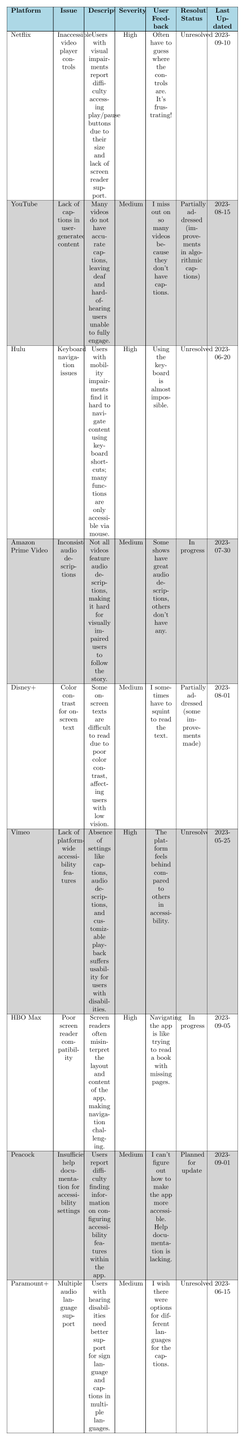What is the issue reported by Hulu? According to the table, Hulu reported "Keyboard navigation issues" as its usability issue.
Answer: Keyboard navigation issues Which platform has a high severity issue related to poor color contrast? The table indicates that Disney+ has a medium severity issue related to color contrast, while the other high severity issues are listed under platforms like Netflix, Hulu, Vimeo, and HBO Max, but none relate to color contrast.
Answer: None How many platforms report unresolved issues? By counting the "Resolution Status" column, there are four platforms (Netflix, Hulu, Vimeo, and Paramount+) that report issues as unresolved.
Answer: Four What is the user feedback for the issue reported by Peacock? The user feedback for Peacock states: "I can't figure out how to make the app more accessible. Help documentation is lacking." This feedback indicates a specific concern related to help documentation.
Answer: "I can't figure out how to make the app more accessible. Help documentation is lacking." Which platform has an issue regarding audio descriptions? The table shows that Amazon Prime Video has the issue of "Inconsistent audio descriptions."
Answer: Amazon Prime Video Are there any platforms that have a resolution status of "In progress"? Yes, both HBO Max and Amazon Prime Video have their resolution status listed as "In progress."
Answer: Yes What is the last updated date for the issue regarding inaccessible video player controls on Netflix? The table provides the last updated date for Netflix's issue as "2023-09-10."
Answer: 2023-09-10 Which platform has the most recent update regarding an unresolved issue? The most recent unresolved issues are reported by Netflix (updated on 2023-09-10), while the unresolved issue for Hulu was last updated on 2023-06-20. Therefore, Netflix is the platform with the most recent update for an unresolved issue.
Answer: Netflix Considering the severity ratings, which platform has the highest number of high severity issues? The platforms Netflix, Hulu, Vimeo, and HBO Max each have one high severity issue, making a total of four platforms with high severity issues, showing no platform stands out with more.
Answer: Four platforms Which platforms are addressing issues partially, and what do their issues concern? YouTube and Disney+ are addressing their issues partially, with YouTube concerning "Lack of captions in user-generated content" and Disney+ having an issue with "Color contrast for on-screen text."
Answer: YouTube and Disney+; lack of captions and color contrast issues 